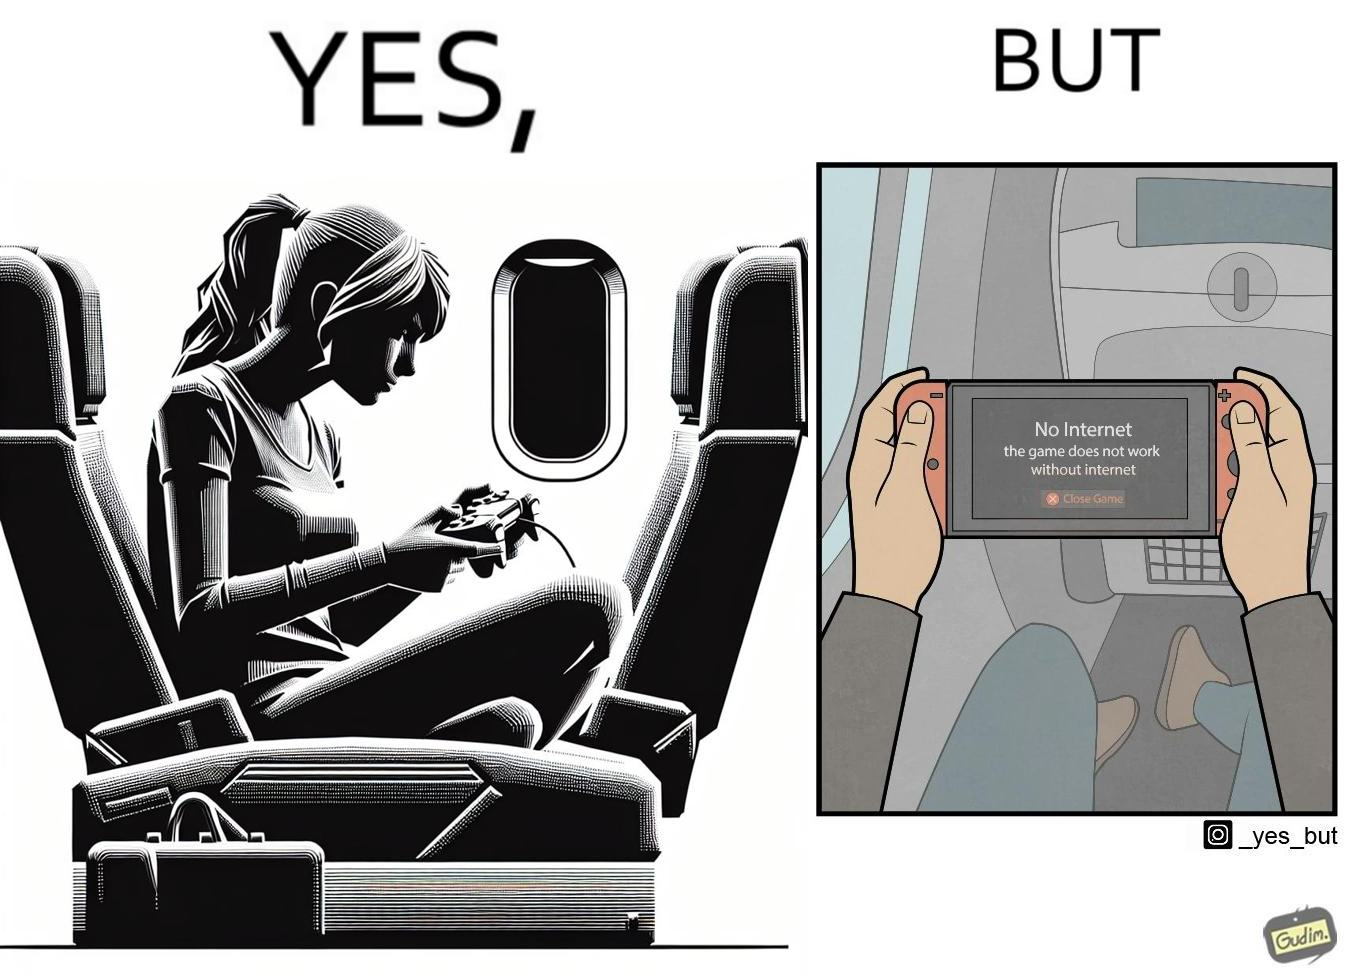Describe the contrast between the left and right parts of this image. In the left part of the image: a person sitting in a flight seat, with a gaming console in the person's hands. In the right part of the image: a person sitting in a flight seat, with a gaming console in the person's hands, with a message which shows "No Internet, the game does not work without internet". 